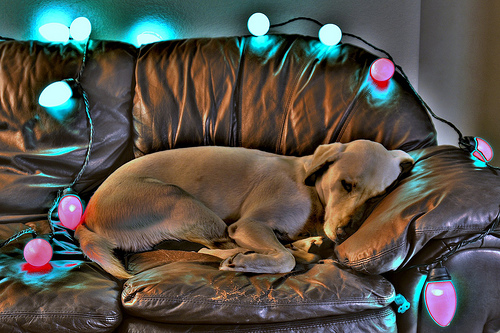<image>
Can you confirm if the dog is on the sofa? Yes. Looking at the image, I can see the dog is positioned on top of the sofa, with the sofa providing support. 